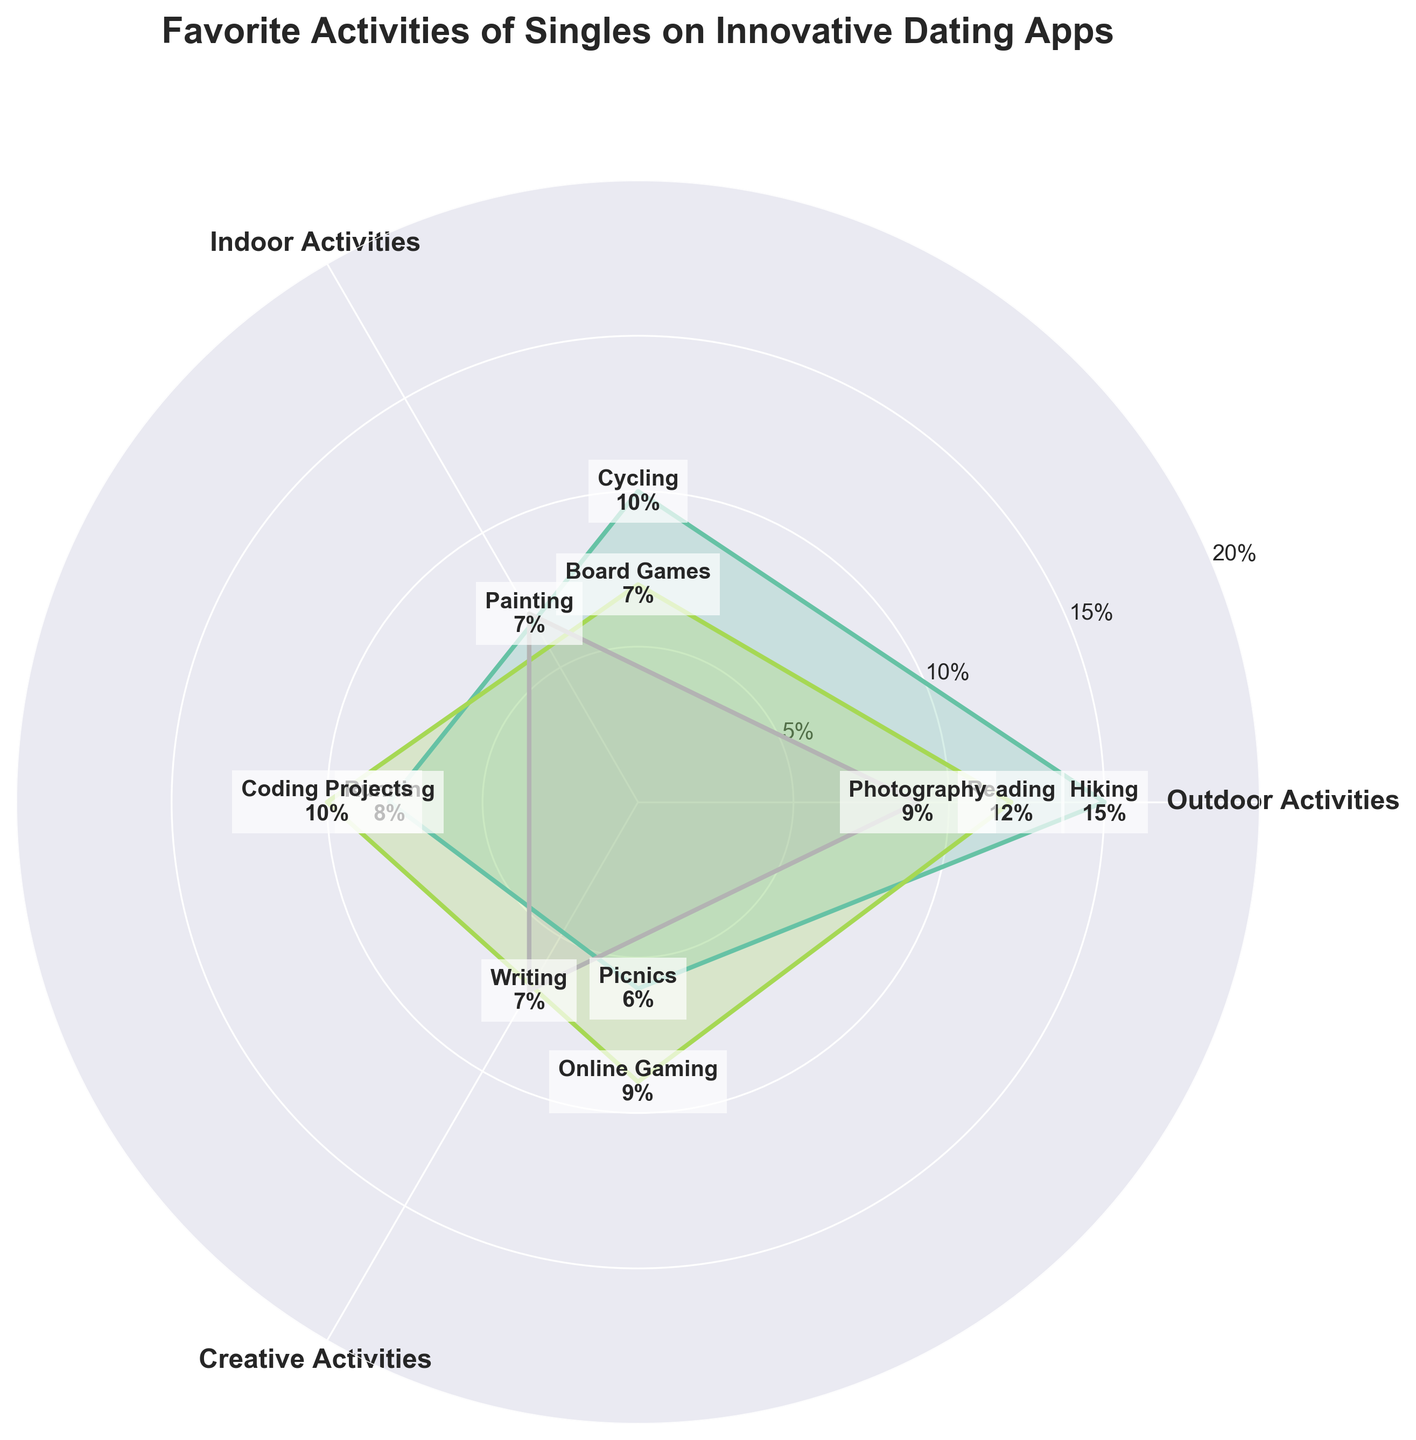What's the title of the figure? The title is displayed at the top center of the figure in bold and larger font size. It describes what the figure is about.
Answer: Favorite Activities of Singles on Innovative Dating Apps How many outdoor activities are represented in the figure? Look for all activities categorized as "Outdoor Activities" in the figure. Counting the segments represented reveals the total number of outdoor activities.
Answer: 4 Which activity has the highest percentage? Identify the segment with the largest filled area or highest percentage value on the figure; outlined and labeled with text showing the highest value.
Answer: Hiking What is the average percentage of indoor activities? Add up all the percentage values of indoor activities (Reading, Board Games, Coding Projects, Online Gaming), then divide by the number of indoor activities.
Answer: (12 + 7 + 10 + 9) / 4 = 38 / 4 = 9.5% Is the percentage of Cycling higher than Reading? Directly compare the percentage values labeled for Cycling and Reading on the figure.
Answer: No What is the difference between the percentages of Painting and Photography? Subtract the percentage value of Photography from Painting based on their respective labeled values on the figure.
Answer: 9 - 7 = 2% What are the main activity categories shown on the figure? Look at the labeled segments on the x-axis around the perimeter of the polar chart to identify the main activity categories.
Answer: Outdoor Activities, Indoor Activities, Creative Activities What is the sum of the percentages of Running and Painting? Add the percentage values of Running and Painting, which are labeled on the figure.
Answer: 8 + 7 = 15% Which activity category has the smallest cumulative percentage? Sum up the percentage values of each activity within a category and compare the totals.
Answer: Creative Activities How does the percentage of Online Gaming compare to that of Writing? Compare the values of Online Gaming and Writing, labeled in their respective segments on the figure.
Answer: Online Gaming is higher 